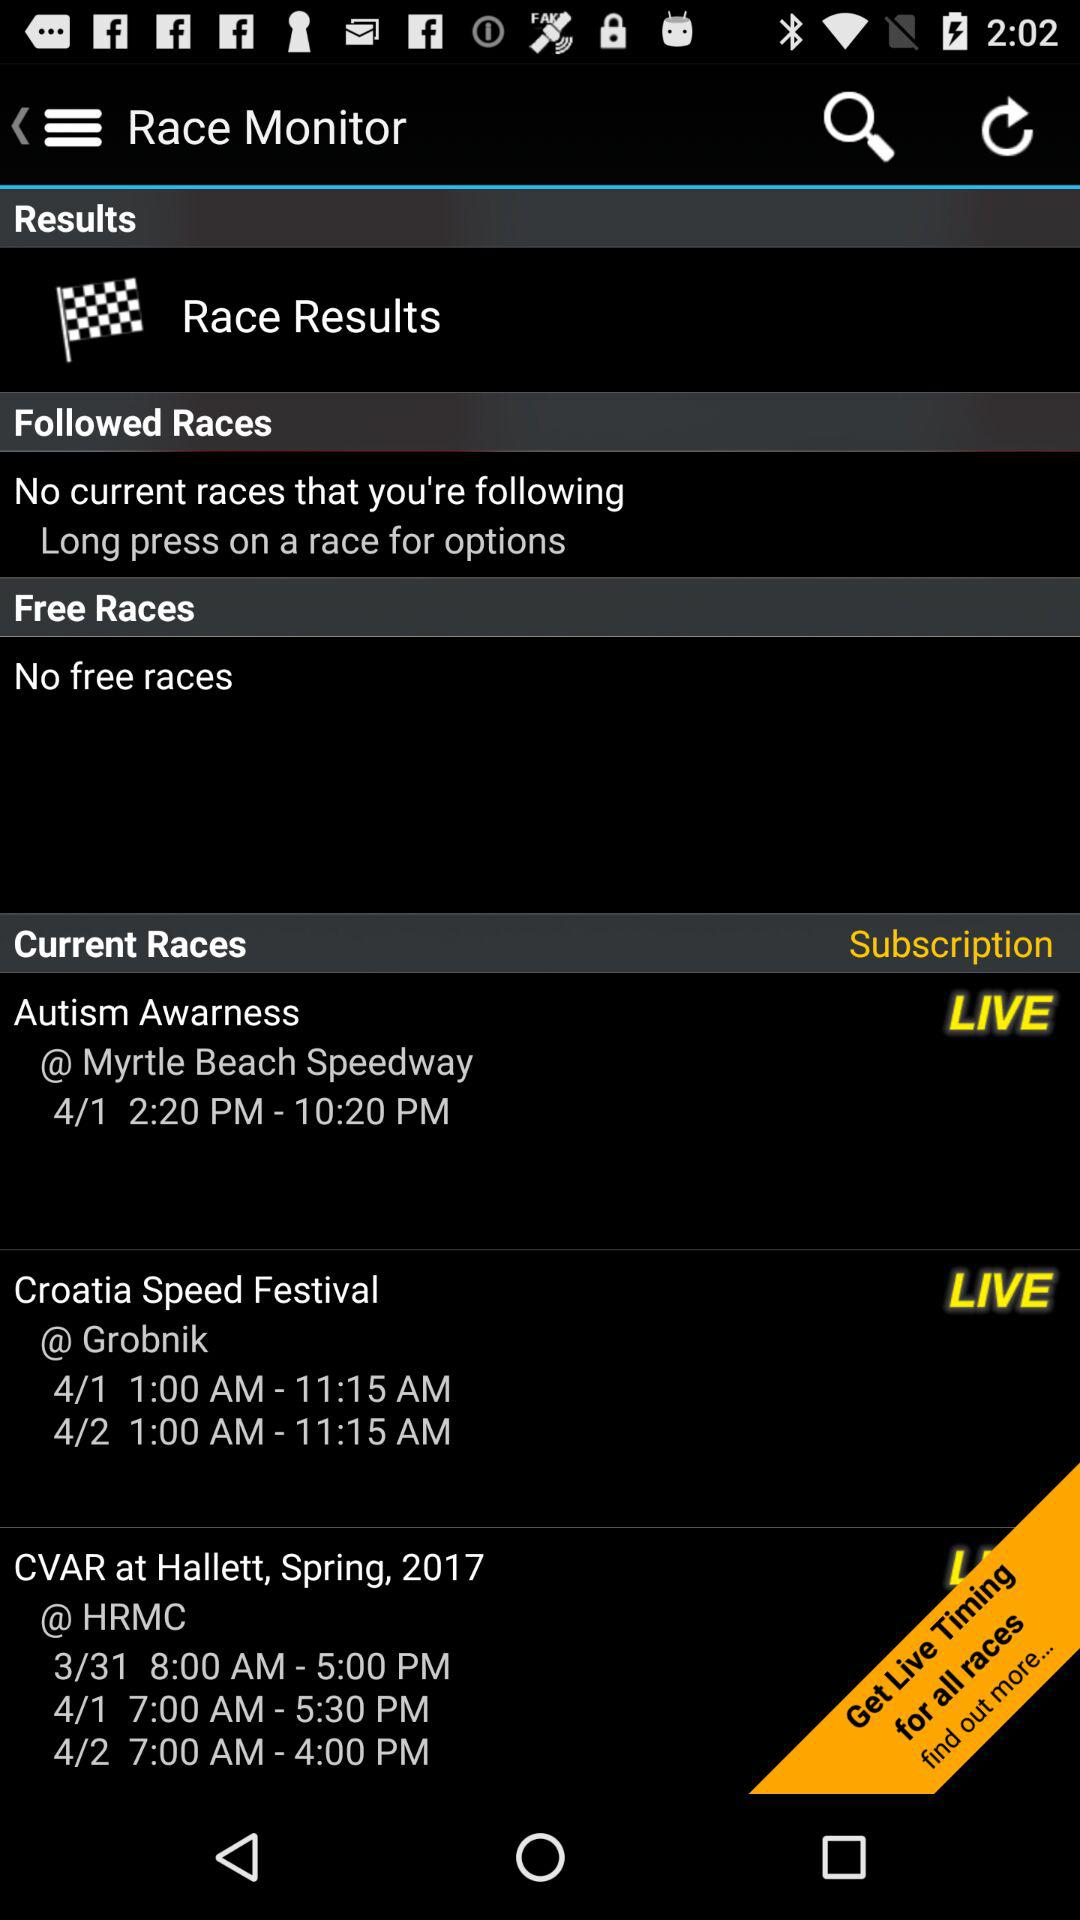What is the timing of Autism Awarness? The timing is 2:20 PM - 10:20 PM. 